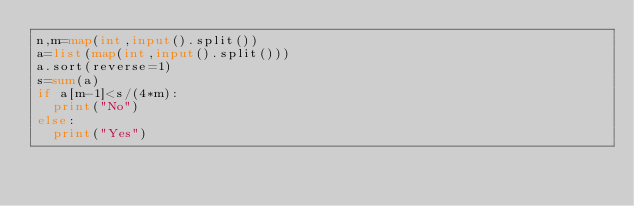Convert code to text. <code><loc_0><loc_0><loc_500><loc_500><_Python_>n,m=map(int,input().split())
a=list(map(int,input().split()))
a.sort(reverse=1)
s=sum(a)
if a[m-1]<s/(4*m):
  print("No")
else:
  print("Yes")</code> 